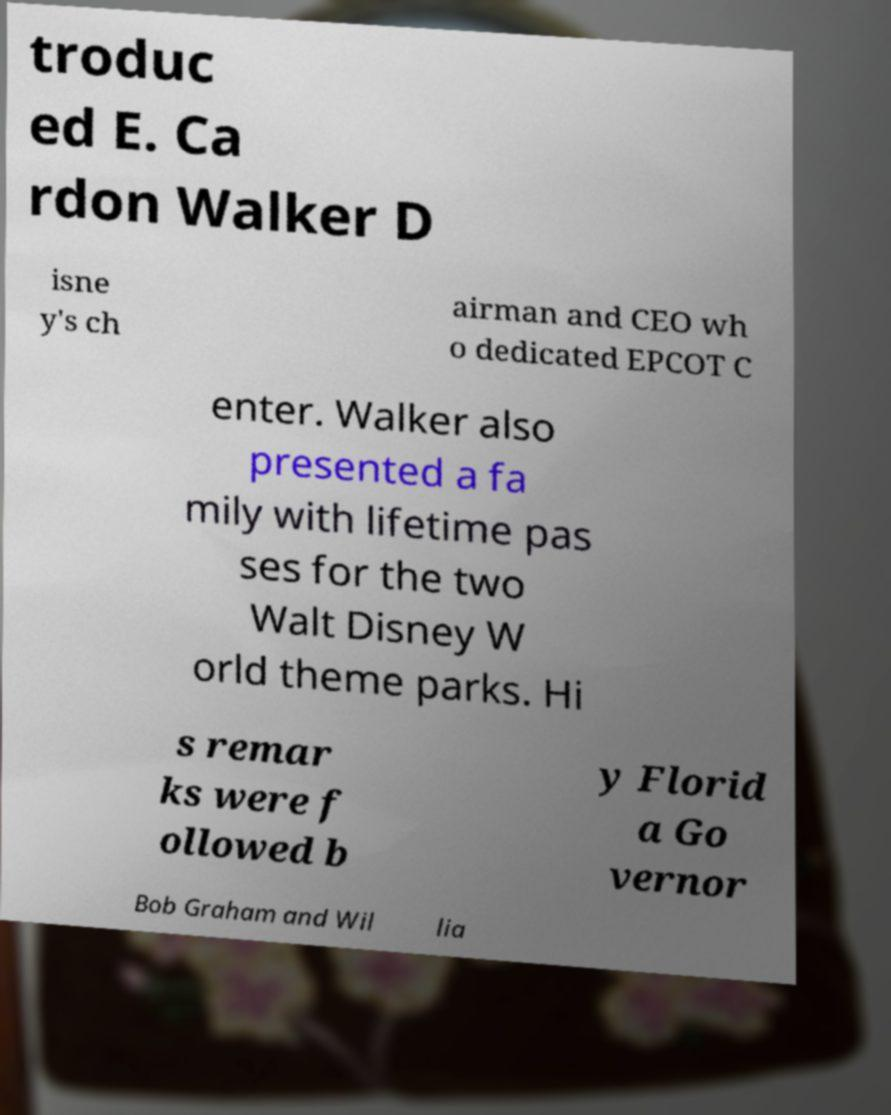What messages or text are displayed in this image? I need them in a readable, typed format. troduc ed E. Ca rdon Walker D isne y's ch airman and CEO wh o dedicated EPCOT C enter. Walker also presented a fa mily with lifetime pas ses for the two Walt Disney W orld theme parks. Hi s remar ks were f ollowed b y Florid a Go vernor Bob Graham and Wil lia 